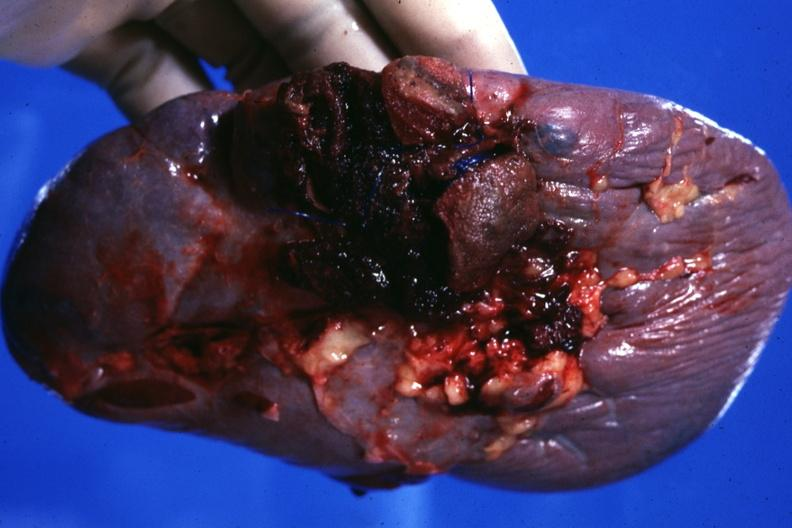what is present?
Answer the question using a single word or phrase. Traumatic rupture 